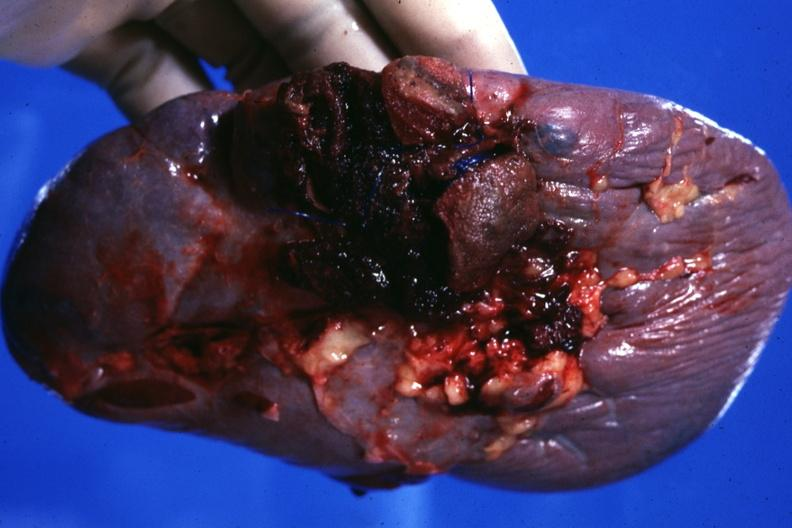what is present?
Answer the question using a single word or phrase. Traumatic rupture 